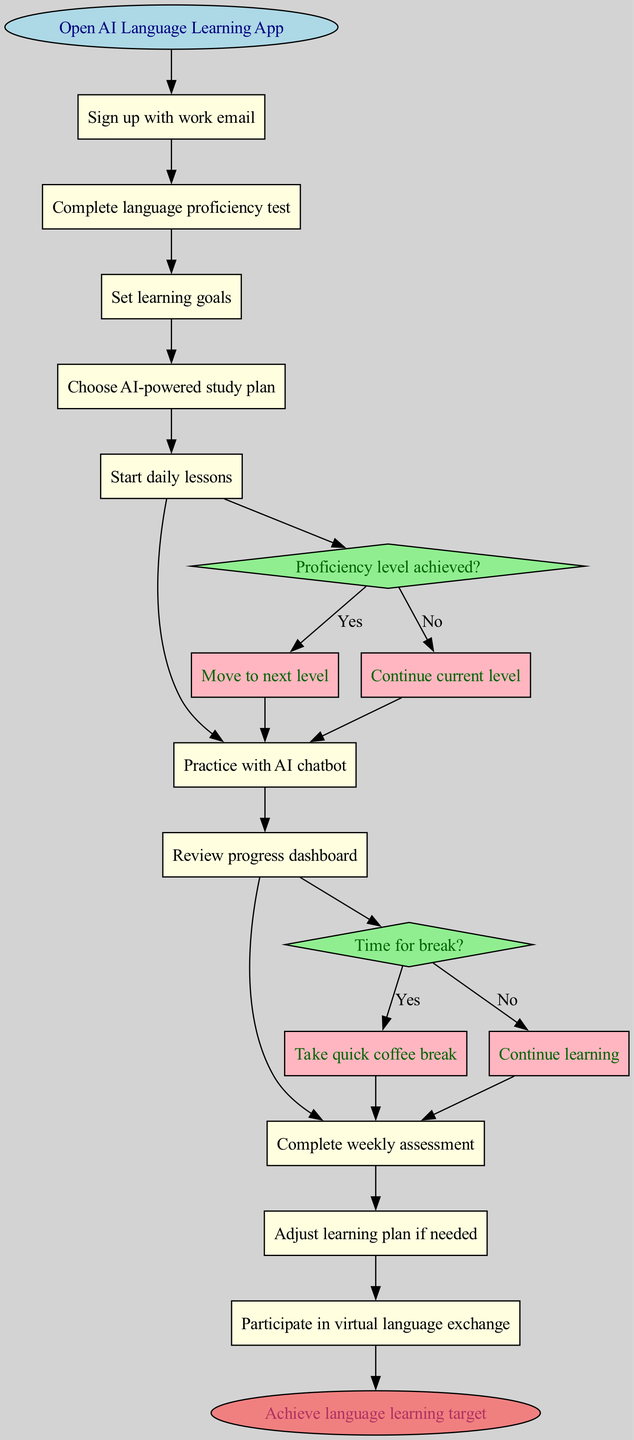What is the starting activity in the user journey? The starting activity is indicated as the first node in the diagram, which describes the initial action a user takes upon engaging with the application. This is labeled as "Open AI Language Learning App."
Answer: Open AI Language Learning App How many decision nodes are present in the diagram? The decision nodes are represented as diamonds in the diagram. There are two decision nodes as listed under the 'decisionNodes' section of the provided data.
Answer: 2 What happens if a user answers 'Yes' to the proficiency level achieved condition? If the user answers 'Yes' to the decision node asking if the proficiency level is achieved, the flow proceeds to the action labeled "Move to next level" as indicated by the edge connected to the 'yes' node for this decision.
Answer: Move to next level What activity follows after the user reviews the progress dashboard? The activity that follows after the user reviews the progress dashboard can be traced by identifying the edge leading from "Review progress dashboard" to its subsequent activity in the flow, which is labeled "Complete weekly assessment."
Answer: Complete weekly assessment What is the final outcome of the user journey? The final outcome is depicted in the diagram as the end node, which captures the ultimate goal achieved by the user after going through the defined activities and decisions in the journey. It is labeled as "Achieve language learning target."
Answer: Achieve language learning target What is the significance of the "Time for break?" decision node? The "Time for break?" decision node introduces a choice into the learning process, allowing the user to either continue learning or take a break based on their current status. This highlights the system's flexibility in accommodating user needs.
Answer: Take quick coffee break or Continue learning Which activity occurs before the user can practice with the AI chatbot? The activity that must be completed before practicing with the AI chatbot is identified in the diagram as the one immediately preceding it, which is labeled "Start daily lessons."
Answer: Start daily lessons What is the first decision the user encounters after starting the daily lessons? The first decision encountered after starting the daily lessons is "Proficiency level achieved?", which dictates subsequent learning actions based on the user's proficiency assessment.
Answer: Proficiency level achieved? 